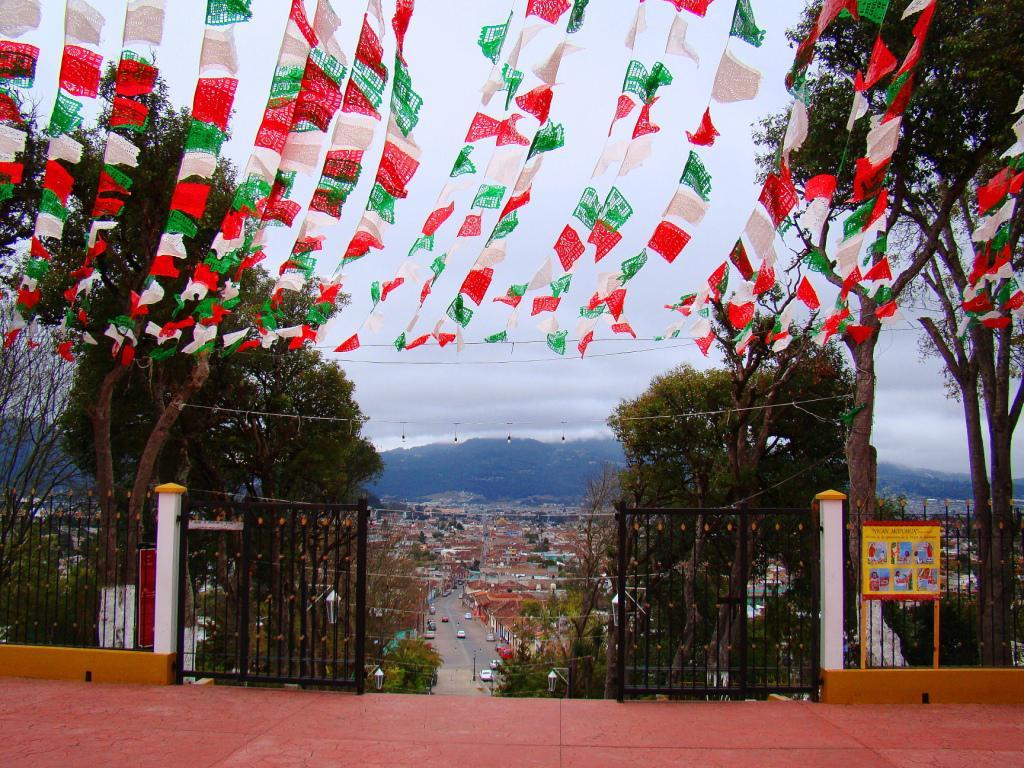What type of structure can be seen in the image? There is a gate in the image. What other structures are present in the image? There is a fence and houses in the image. What type of decoration is present in the image? Decoration flags are present in the image. What natural elements can be seen in the image? There are trees and hills visible in the image. What is happening on the road in the image? Vehicles are moving on the road in the image. What can be seen in the background of the image? The sky with clouds is visible in the background of the image. Where is the table located in the image? There is no table present in the image. What is the chance of rain in the image? The image does not provide any information about the chance of rain. 